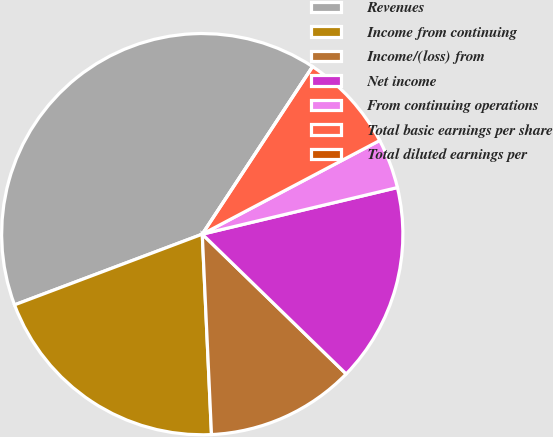Convert chart. <chart><loc_0><loc_0><loc_500><loc_500><pie_chart><fcel>Revenues<fcel>Income from continuing<fcel>Income/(loss) from<fcel>Net income<fcel>From continuing operations<fcel>Total basic earnings per share<fcel>Total diluted earnings per<nl><fcel>40.0%<fcel>20.0%<fcel>12.0%<fcel>16.0%<fcel>4.0%<fcel>8.0%<fcel>0.0%<nl></chart> 